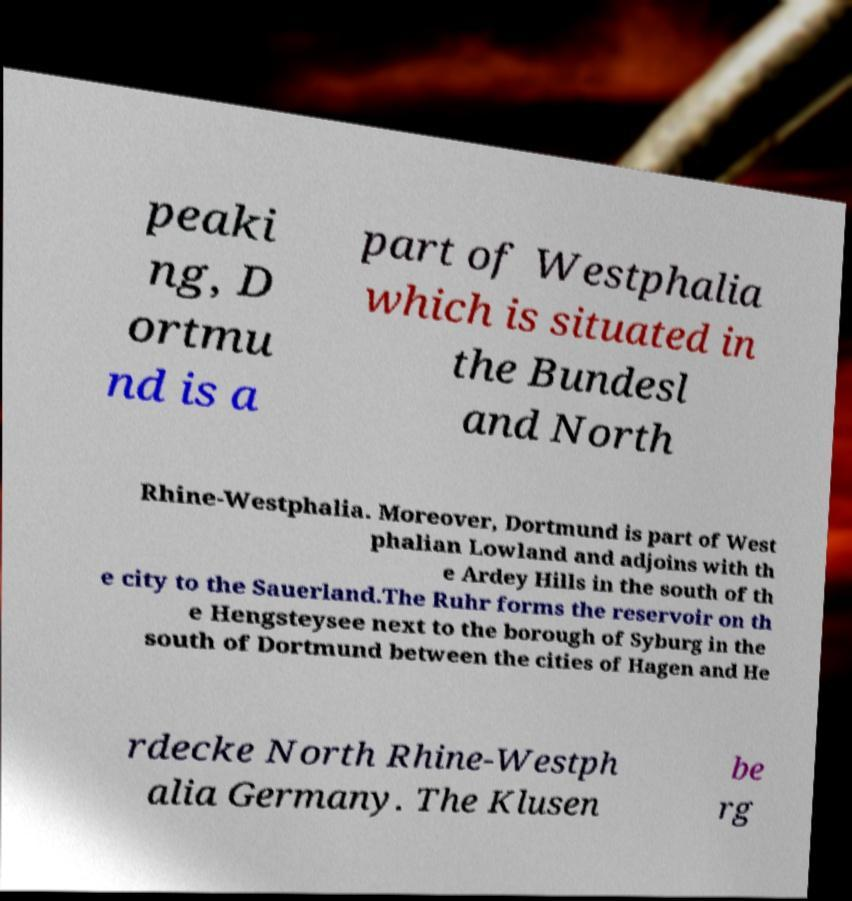Can you read and provide the text displayed in the image?This photo seems to have some interesting text. Can you extract and type it out for me? peaki ng, D ortmu nd is a part of Westphalia which is situated in the Bundesl and North Rhine-Westphalia. Moreover, Dortmund is part of West phalian Lowland and adjoins with th e Ardey Hills in the south of th e city to the Sauerland.The Ruhr forms the reservoir on th e Hengsteysee next to the borough of Syburg in the south of Dortmund between the cities of Hagen and He rdecke North Rhine-Westph alia Germany. The Klusen be rg 